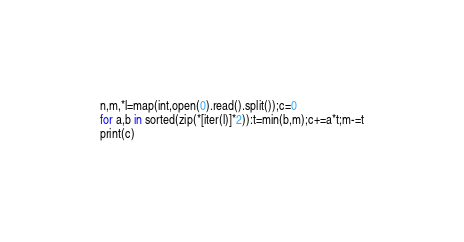<code> <loc_0><loc_0><loc_500><loc_500><_Python_>n,m,*l=map(int,open(0).read().split());c=0
for a,b in sorted(zip(*[iter(l)]*2)):t=min(b,m);c+=a*t;m-=t
print(c)</code> 